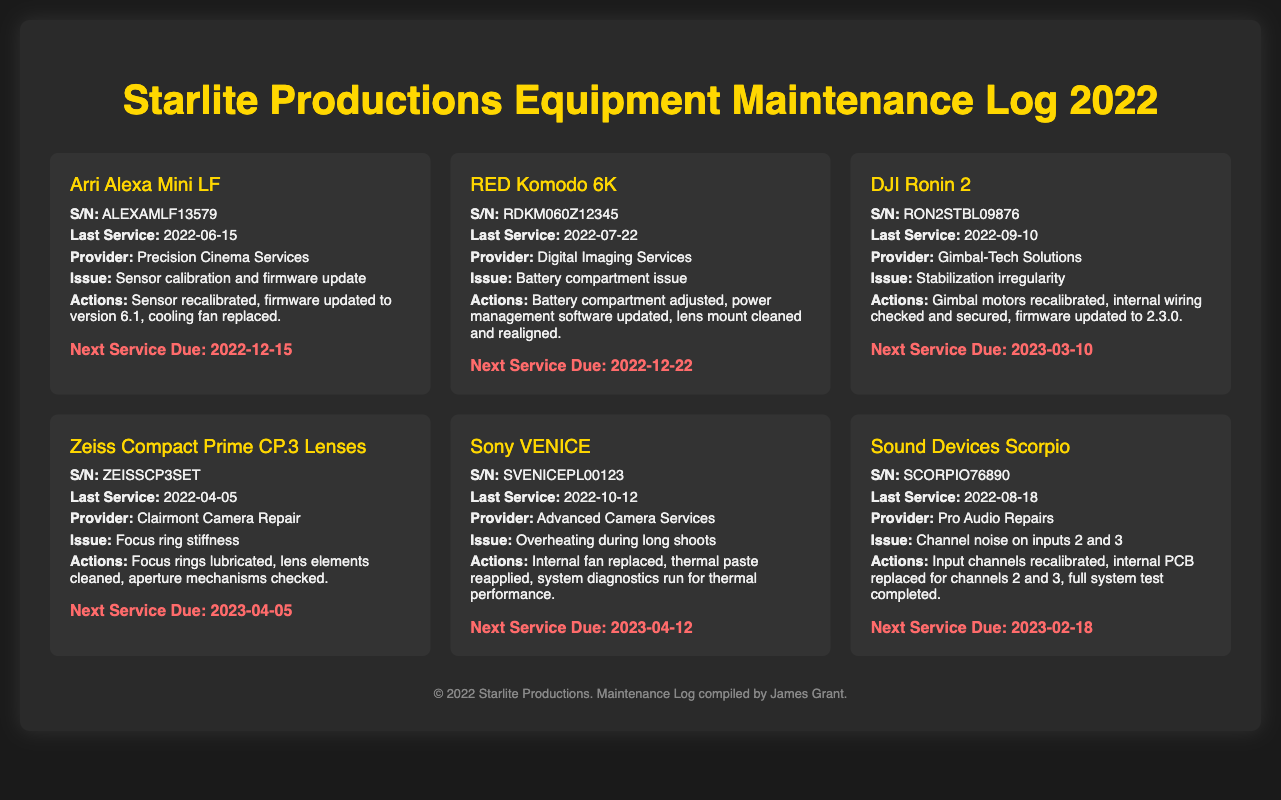what is the name of the first equipment listed? The first equipment listed in the log is the Arri Alexa Mini LF.
Answer: Arri Alexa Mini LF when was the last service performed on the RED Komodo 6K? The last service date for the RED Komodo 6K is found in the document, which is July 22, 2022.
Answer: 2022-07-22 what issue was addressed during the last service of the Sony VENICE? The document specifies the issue for the Sony VENICE was overheating during long shoots.
Answer: Overheating during long shoots who provided service for the DJI Ronin 2? The service provider for the DJI Ronin 2 is mentioned as Gimbal-Tech Solutions in the document.
Answer: Gimbal-Tech Solutions when is the next service due for the Sound Devices Scorpio? The document indicates the next service due for the Sound Devices Scorpio is on February 18, 2023.
Answer: 2023-02-18 how many equipment entries are listed in the log? The document presents a total of six equipment entries.
Answer: 6 what action was taken for the Zeiss Compact Prime CP.3 Lenses during the last service? According to the document, the focus rings were lubricated for the Zeiss Compact Prime CP.3 Lenses.
Answer: Focus rings lubricated what was the last service date of the Arri Alexa Mini LF? The last service date recorded for the Arri Alexa Mini LF is June 15, 2022, according to the maintenance log.
Answer: 2022-06-15 